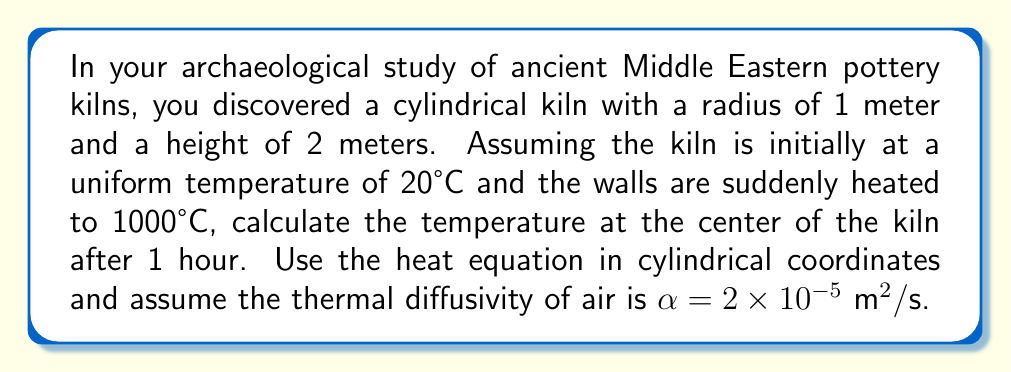What is the answer to this math problem? 1) The heat equation in cylindrical coordinates is:

   $$\frac{\partial T}{\partial t} = \alpha \left(\frac{\partial^2 T}{\partial r^2} + \frac{1}{r}\frac{\partial T}{\partial r} + \frac{\partial^2 T}{\partial z^2}\right)$$

2) Given the symmetry of the problem, we can assume the temperature only depends on r and t. The equation simplifies to:

   $$\frac{\partial T}{\partial t} = \alpha \left(\frac{\partial^2 T}{\partial r^2} + \frac{1}{r}\frac{\partial T}{\partial r}\right)$$

3) The boundary conditions are:
   $T(r,0) = 20$ for $0 \leq r < 1$ (initial condition)
   $T(1,t) = 1000$ for $t > 0$ (boundary condition)

4) The solution to this problem is given by:

   $$T(r,t) = 1000 + (20-1000)\frac{2}{R}\sum_{n=1}^{\infty}\frac{J_0(r\lambda_n)}{J_1(R\lambda_n)}e^{-\alpha\lambda_n^2t}$$

   where $J_0$ and $J_1$ are Bessel functions of the first kind, $R$ is the radius, and $\lambda_n$ are the positive roots of $J_0(R\lambda_n) = 0$.

5) At the center, $r=0$. Using the property $J_0(0)=1$, we get:

   $$T(0,t) = 1000 + (20-1000)\frac{2}{R}\sum_{n=1}^{\infty}\frac{1}{J_1(R\lambda_n)}e^{-\alpha\lambda_n^2t}$$

6) For practical purposes, we can truncate the series after a few terms. Let's use the first three roots: $\lambda_1 \approx 2.4048$, $\lambda_2 \approx 5.5201$, $\lambda_3 \approx 8.6537$.

7) Substituting the values:
   $R = 1$, $t = 3600$ s, $\alpha = 2 \times 10^{-5} \text{ m}^2/\text{s}$

8) Calculating:
   $$T(0,3600) \approx 1000 - 980 \cdot 2 \left(\frac{e^{-2.4048^2 \cdot 2 \times 10^{-5} \cdot 3600}}{J_1(2.4048)} + \frac{e^{-5.5201^2 \cdot 2 \times 10^{-5} \cdot 3600}}{J_1(5.5201)} + \frac{e^{-8.6537^2 \cdot 2 \times 10^{-5} \cdot 3600}}{J_1(8.6537)}\right)$$

9) Evaluating this expression numerically gives approximately 878.5°C.
Answer: 878.5°C 